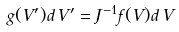Convert formula to latex. <formula><loc_0><loc_0><loc_500><loc_500>g ( V ^ { \prime } ) d \, V ^ { \prime } = J ^ { - 1 } f ( V ) d \, V</formula> 